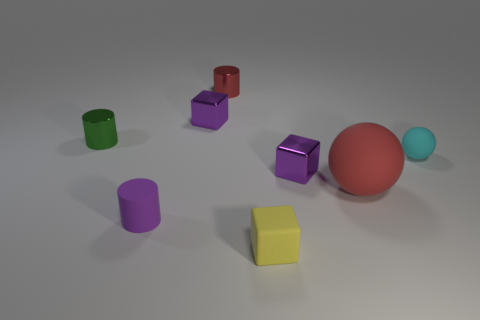How many purple cubes must be subtracted to get 1 purple cubes? 1 Subtract all purple cylinders. How many cylinders are left? 2 Add 1 small green metallic objects. How many objects exist? 9 Subtract all cylinders. How many objects are left? 5 Subtract all red balls. How many balls are left? 1 Subtract 1 spheres. How many spheres are left? 1 Subtract all yellow balls. How many purple cubes are left? 2 Add 6 tiny yellow rubber objects. How many tiny yellow rubber objects are left? 7 Add 4 small purple metal cylinders. How many small purple metal cylinders exist? 4 Subtract 0 brown blocks. How many objects are left? 8 